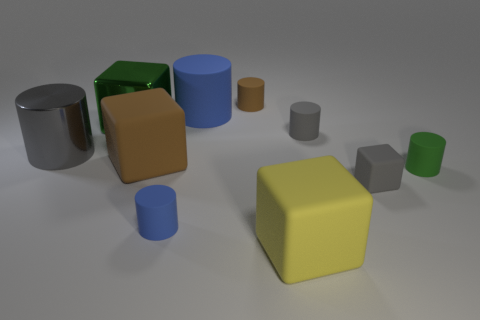Subtract all green cylinders. How many cylinders are left? 5 Subtract all green blocks. How many blocks are left? 3 Subtract all cyan cubes. Subtract all gray spheres. How many cubes are left? 4 Subtract all cylinders. How many objects are left? 4 Subtract 1 green cylinders. How many objects are left? 9 Subtract all big red rubber objects. Subtract all blue objects. How many objects are left? 8 Add 7 gray cubes. How many gray cubes are left? 8 Add 1 big blue balls. How many big blue balls exist? 1 